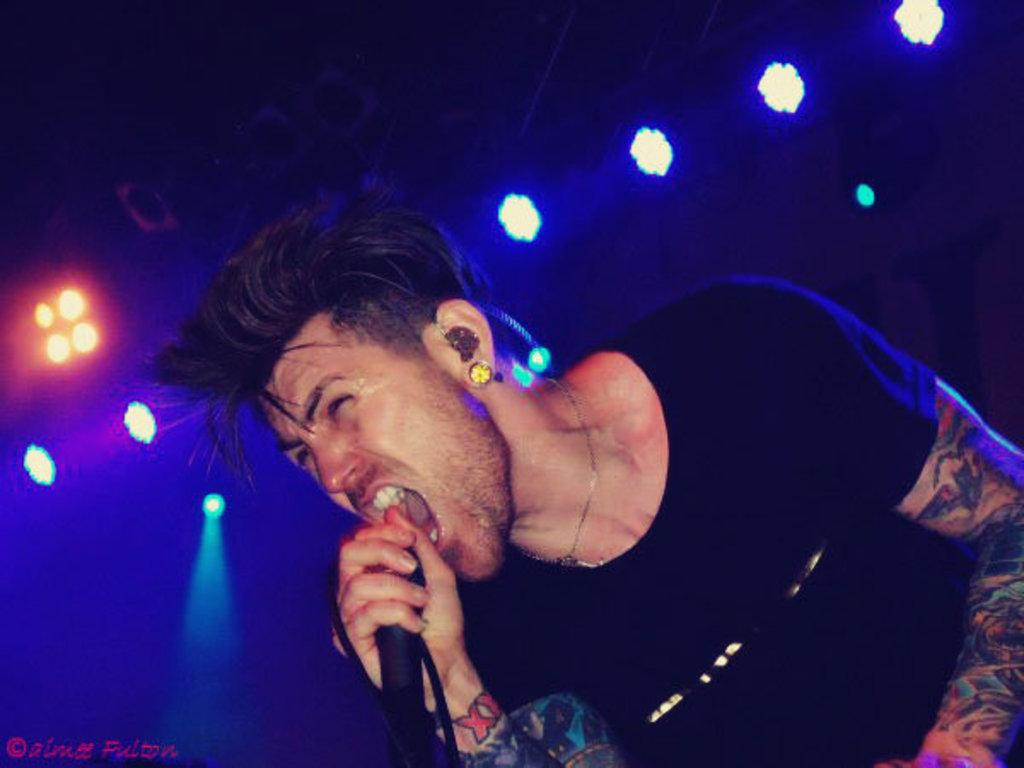What can be seen in the image? There is a person in the image. What is the person wearing? The person is wearing a t-shirt. What is the person holding in the image? The person is holding a microphone. What can be seen in the background of the image? There is a group of lights in the background of the image. What is visible at the bottom of the image? There is some text visible at the bottom of the image. What type of disease is the person suffering from in the image? There is no indication in the image that the person is suffering from any disease. 